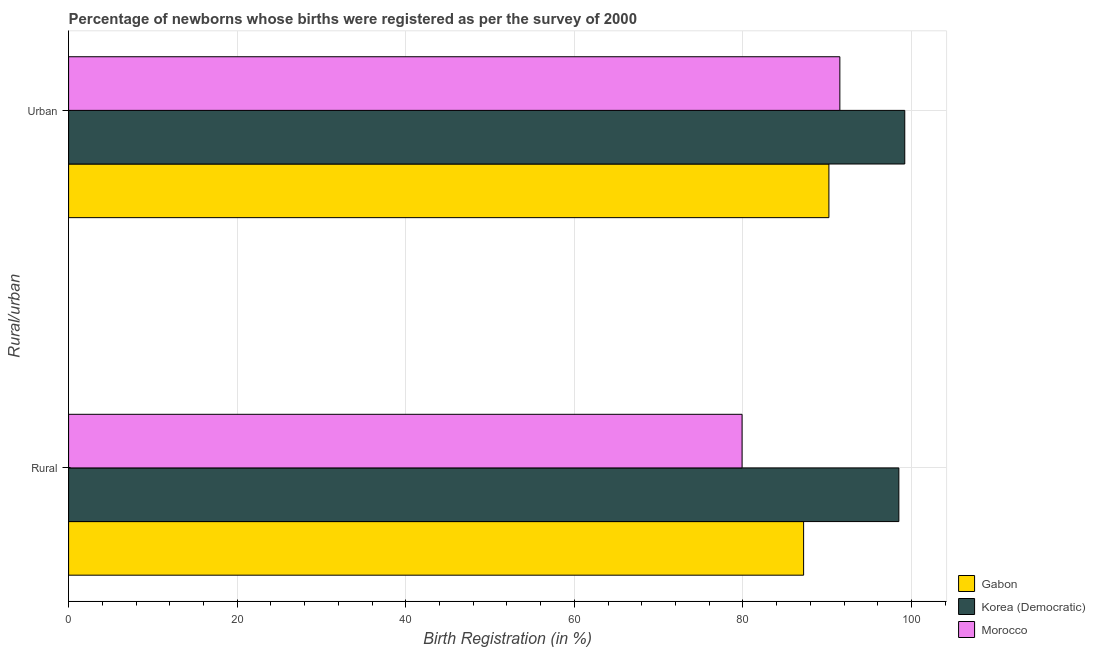How many groups of bars are there?
Provide a succinct answer. 2. Are the number of bars on each tick of the Y-axis equal?
Keep it short and to the point. Yes. How many bars are there on the 1st tick from the top?
Offer a very short reply. 3. How many bars are there on the 2nd tick from the bottom?
Keep it short and to the point. 3. What is the label of the 2nd group of bars from the top?
Provide a succinct answer. Rural. What is the rural birth registration in Korea (Democratic)?
Provide a succinct answer. 98.5. Across all countries, what is the maximum urban birth registration?
Provide a succinct answer. 99.2. Across all countries, what is the minimum rural birth registration?
Your answer should be compact. 79.9. In which country was the urban birth registration maximum?
Your answer should be compact. Korea (Democratic). In which country was the urban birth registration minimum?
Your answer should be compact. Gabon. What is the total urban birth registration in the graph?
Keep it short and to the point. 280.9. What is the difference between the urban birth registration in Gabon and that in Korea (Democratic)?
Your answer should be compact. -9. What is the difference between the urban birth registration in Korea (Democratic) and the rural birth registration in Morocco?
Make the answer very short. 19.3. What is the average rural birth registration per country?
Provide a short and direct response. 88.53. What is the difference between the urban birth registration and rural birth registration in Korea (Democratic)?
Give a very brief answer. 0.7. What is the ratio of the rural birth registration in Gabon to that in Morocco?
Make the answer very short. 1.09. What does the 1st bar from the top in Urban represents?
Provide a short and direct response. Morocco. What does the 3rd bar from the bottom in Rural represents?
Your response must be concise. Morocco. Are all the bars in the graph horizontal?
Your answer should be compact. Yes. How many countries are there in the graph?
Ensure brevity in your answer.  3. Are the values on the major ticks of X-axis written in scientific E-notation?
Keep it short and to the point. No. Does the graph contain any zero values?
Offer a terse response. No. Where does the legend appear in the graph?
Your response must be concise. Bottom right. How are the legend labels stacked?
Offer a very short reply. Vertical. What is the title of the graph?
Offer a very short reply. Percentage of newborns whose births were registered as per the survey of 2000. What is the label or title of the X-axis?
Make the answer very short. Birth Registration (in %). What is the label or title of the Y-axis?
Your answer should be very brief. Rural/urban. What is the Birth Registration (in %) in Gabon in Rural?
Your answer should be compact. 87.2. What is the Birth Registration (in %) in Korea (Democratic) in Rural?
Give a very brief answer. 98.5. What is the Birth Registration (in %) in Morocco in Rural?
Provide a short and direct response. 79.9. What is the Birth Registration (in %) in Gabon in Urban?
Provide a short and direct response. 90.2. What is the Birth Registration (in %) in Korea (Democratic) in Urban?
Provide a succinct answer. 99.2. What is the Birth Registration (in %) in Morocco in Urban?
Provide a succinct answer. 91.5. Across all Rural/urban, what is the maximum Birth Registration (in %) in Gabon?
Offer a very short reply. 90.2. Across all Rural/urban, what is the maximum Birth Registration (in %) of Korea (Democratic)?
Offer a terse response. 99.2. Across all Rural/urban, what is the maximum Birth Registration (in %) of Morocco?
Provide a short and direct response. 91.5. Across all Rural/urban, what is the minimum Birth Registration (in %) in Gabon?
Provide a short and direct response. 87.2. Across all Rural/urban, what is the minimum Birth Registration (in %) in Korea (Democratic)?
Your answer should be compact. 98.5. Across all Rural/urban, what is the minimum Birth Registration (in %) in Morocco?
Provide a short and direct response. 79.9. What is the total Birth Registration (in %) in Gabon in the graph?
Your response must be concise. 177.4. What is the total Birth Registration (in %) of Korea (Democratic) in the graph?
Provide a short and direct response. 197.7. What is the total Birth Registration (in %) in Morocco in the graph?
Offer a very short reply. 171.4. What is the difference between the Birth Registration (in %) of Gabon in Rural and that in Urban?
Keep it short and to the point. -3. What is the difference between the Birth Registration (in %) of Morocco in Rural and that in Urban?
Keep it short and to the point. -11.6. What is the difference between the Birth Registration (in %) of Gabon in Rural and the Birth Registration (in %) of Korea (Democratic) in Urban?
Your response must be concise. -12. What is the difference between the Birth Registration (in %) in Gabon in Rural and the Birth Registration (in %) in Morocco in Urban?
Your response must be concise. -4.3. What is the difference between the Birth Registration (in %) of Korea (Democratic) in Rural and the Birth Registration (in %) of Morocco in Urban?
Keep it short and to the point. 7. What is the average Birth Registration (in %) in Gabon per Rural/urban?
Keep it short and to the point. 88.7. What is the average Birth Registration (in %) in Korea (Democratic) per Rural/urban?
Make the answer very short. 98.85. What is the average Birth Registration (in %) in Morocco per Rural/urban?
Provide a succinct answer. 85.7. What is the difference between the Birth Registration (in %) of Gabon and Birth Registration (in %) of Korea (Democratic) in Rural?
Make the answer very short. -11.3. What is the difference between the Birth Registration (in %) of Gabon and Birth Registration (in %) of Morocco in Urban?
Offer a terse response. -1.3. What is the ratio of the Birth Registration (in %) in Gabon in Rural to that in Urban?
Offer a very short reply. 0.97. What is the ratio of the Birth Registration (in %) in Korea (Democratic) in Rural to that in Urban?
Offer a terse response. 0.99. What is the ratio of the Birth Registration (in %) of Morocco in Rural to that in Urban?
Make the answer very short. 0.87. What is the difference between the highest and the second highest Birth Registration (in %) of Gabon?
Provide a short and direct response. 3. What is the difference between the highest and the second highest Birth Registration (in %) in Korea (Democratic)?
Your answer should be very brief. 0.7. What is the difference between the highest and the second highest Birth Registration (in %) of Morocco?
Your response must be concise. 11.6. What is the difference between the highest and the lowest Birth Registration (in %) of Gabon?
Your response must be concise. 3. What is the difference between the highest and the lowest Birth Registration (in %) in Morocco?
Offer a very short reply. 11.6. 